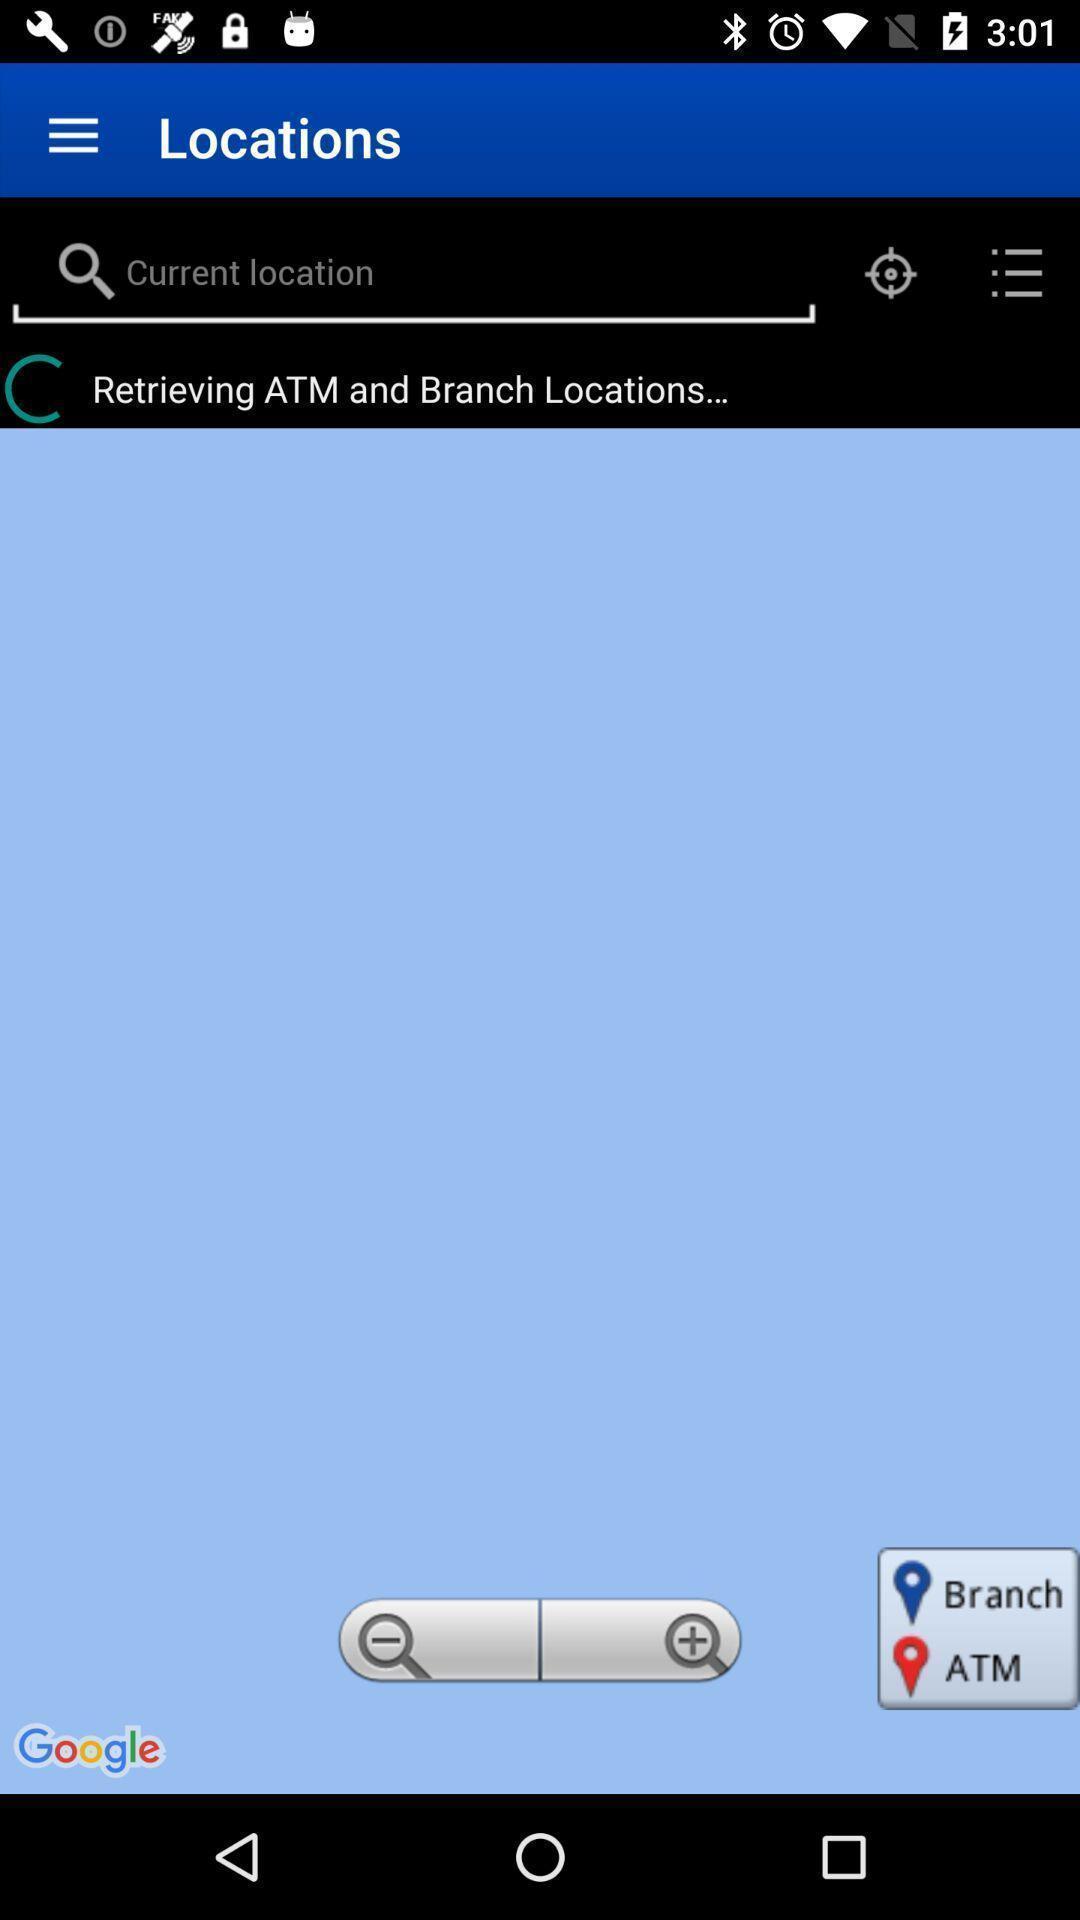Explain the elements present in this screenshot. Window displaying about account information app. 